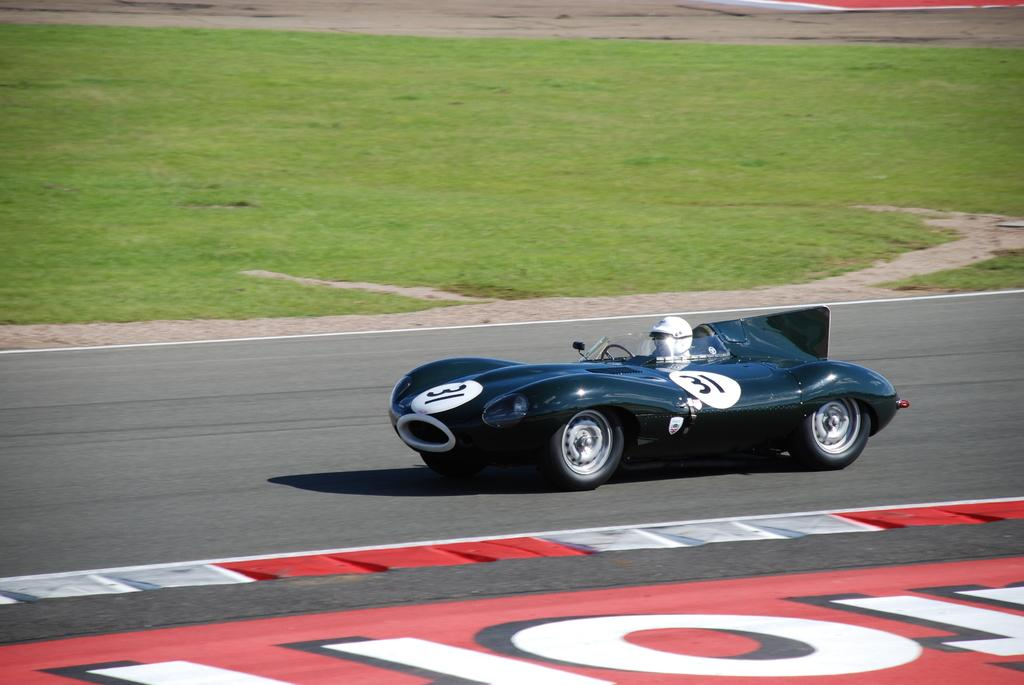What type of vehicle is in the image? There is a racing car in the image. Who is inside the car? A human is sitting inside the car. What safety gear is the person wearing? The person is wearing a helmet. What type of terrain is visible beside the car? There is grass visible beside the car. Where is the car traveling? The car is traveling on a road. What type of punishment is being given to the town in the image? There is no town or punishment present in the image; it features a racing car with a person inside. What substance is being used to lead the car in the image? There is no substance being used to lead the car in the image; the car is traveling on a road. 